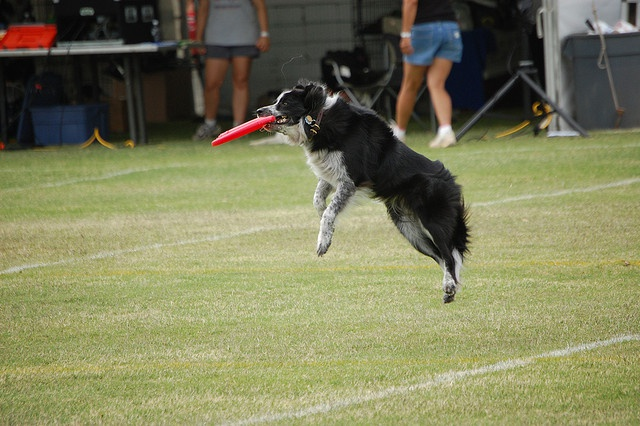Describe the objects in this image and their specific colors. I can see dog in black, gray, and darkgray tones, people in black, brown, blue, and gray tones, people in black, gray, and maroon tones, backpack in black and maroon tones, and frisbee in black, red, lightpink, and pink tones in this image. 